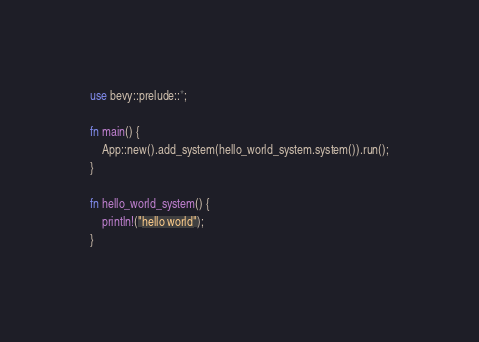Convert code to text. <code><loc_0><loc_0><loc_500><loc_500><_Rust_>use bevy::prelude::*;

fn main() {
    App::new().add_system(hello_world_system.system()).run();
}

fn hello_world_system() {
    println!("hello world");
}
</code> 